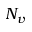Convert formula to latex. <formula><loc_0><loc_0><loc_500><loc_500>N _ { v }</formula> 